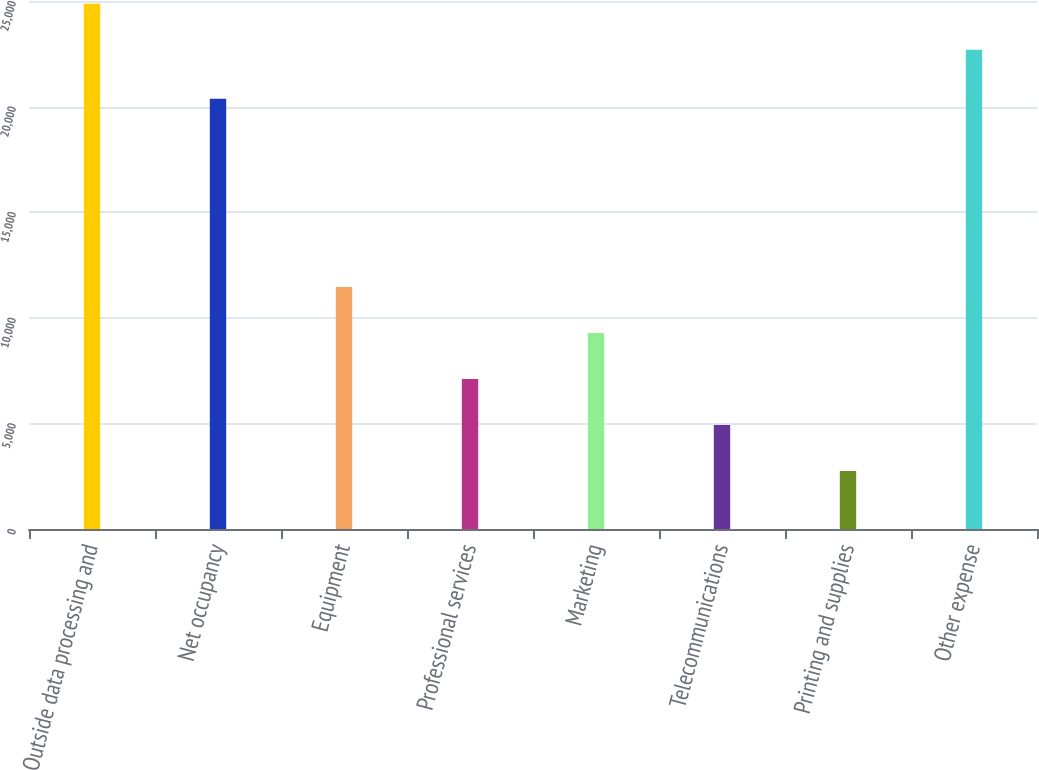Convert chart. <chart><loc_0><loc_0><loc_500><loc_500><bar_chart><fcel>Outside data processing and<fcel>Net occupancy<fcel>Equipment<fcel>Professional services<fcel>Marketing<fcel>Telecommunications<fcel>Printing and supplies<fcel>Other expense<nl><fcel>24873.6<fcel>20368<fcel>11458.4<fcel>7103.2<fcel>9280.8<fcel>4925.6<fcel>2748<fcel>22696<nl></chart> 